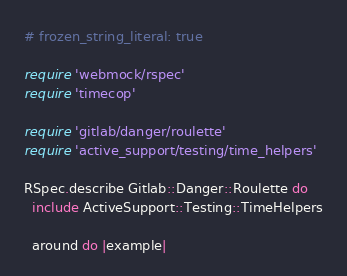Convert code to text. <code><loc_0><loc_0><loc_500><loc_500><_Ruby_># frozen_string_literal: true

require 'webmock/rspec'
require 'timecop'

require 'gitlab/danger/roulette'
require 'active_support/testing/time_helpers'

RSpec.describe Gitlab::Danger::Roulette do
  include ActiveSupport::Testing::TimeHelpers

  around do |example|</code> 